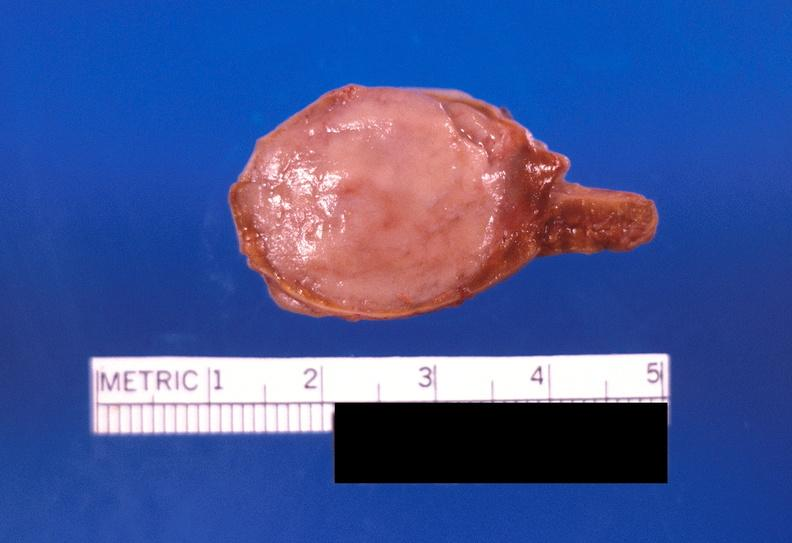s stillborn macerated present?
Answer the question using a single word or phrase. No 